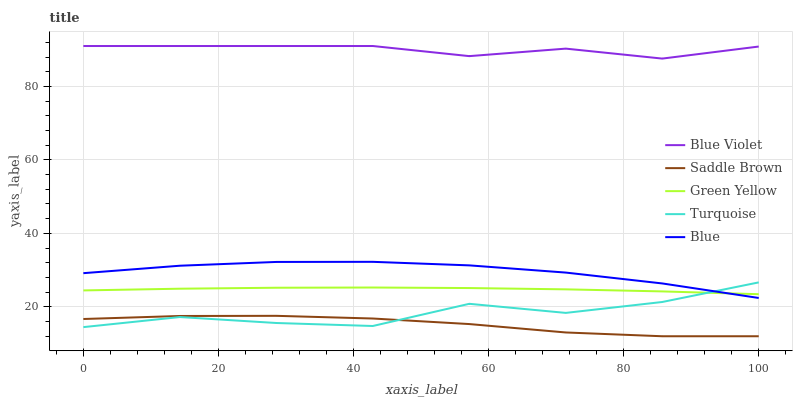Does Saddle Brown have the minimum area under the curve?
Answer yes or no. Yes. Does Blue Violet have the maximum area under the curve?
Answer yes or no. Yes. Does Turquoise have the minimum area under the curve?
Answer yes or no. No. Does Turquoise have the maximum area under the curve?
Answer yes or no. No. Is Green Yellow the smoothest?
Answer yes or no. Yes. Is Turquoise the roughest?
Answer yes or no. Yes. Is Turquoise the smoothest?
Answer yes or no. No. Is Green Yellow the roughest?
Answer yes or no. No. Does Saddle Brown have the lowest value?
Answer yes or no. Yes. Does Turquoise have the lowest value?
Answer yes or no. No. Does Blue Violet have the highest value?
Answer yes or no. Yes. Does Turquoise have the highest value?
Answer yes or no. No. Is Blue less than Blue Violet?
Answer yes or no. Yes. Is Blue greater than Saddle Brown?
Answer yes or no. Yes. Does Saddle Brown intersect Turquoise?
Answer yes or no. Yes. Is Saddle Brown less than Turquoise?
Answer yes or no. No. Is Saddle Brown greater than Turquoise?
Answer yes or no. No. Does Blue intersect Blue Violet?
Answer yes or no. No. 